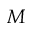Convert formula to latex. <formula><loc_0><loc_0><loc_500><loc_500>M</formula> 